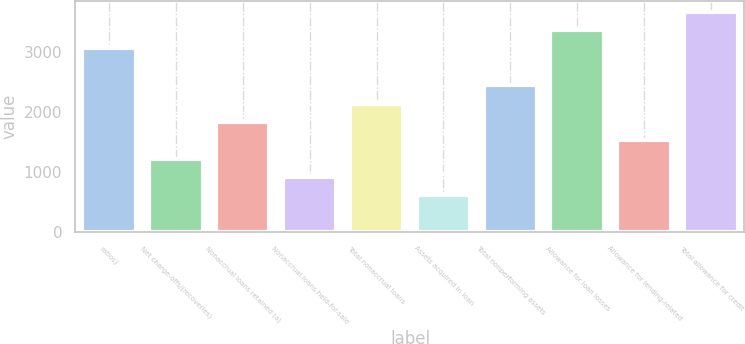Convert chart to OTSL. <chart><loc_0><loc_0><loc_500><loc_500><bar_chart><fcel>ratios)<fcel>Net charge-offs/(recoveries)<fcel>Nonaccrual loans retained (a)<fcel>Nonaccrual loans held-for-sale<fcel>Total nonaccrual loans<fcel>Assets acquired in loan<fcel>Total nonperforming assets<fcel>Allowance for loan losses<fcel>Allowance for lending-related<fcel>Total allowance for credit<nl><fcel>3053.03<fcel>1221.35<fcel>1831.91<fcel>916.07<fcel>2137.19<fcel>610.79<fcel>2442.47<fcel>3358.31<fcel>1526.63<fcel>3663.59<nl></chart> 